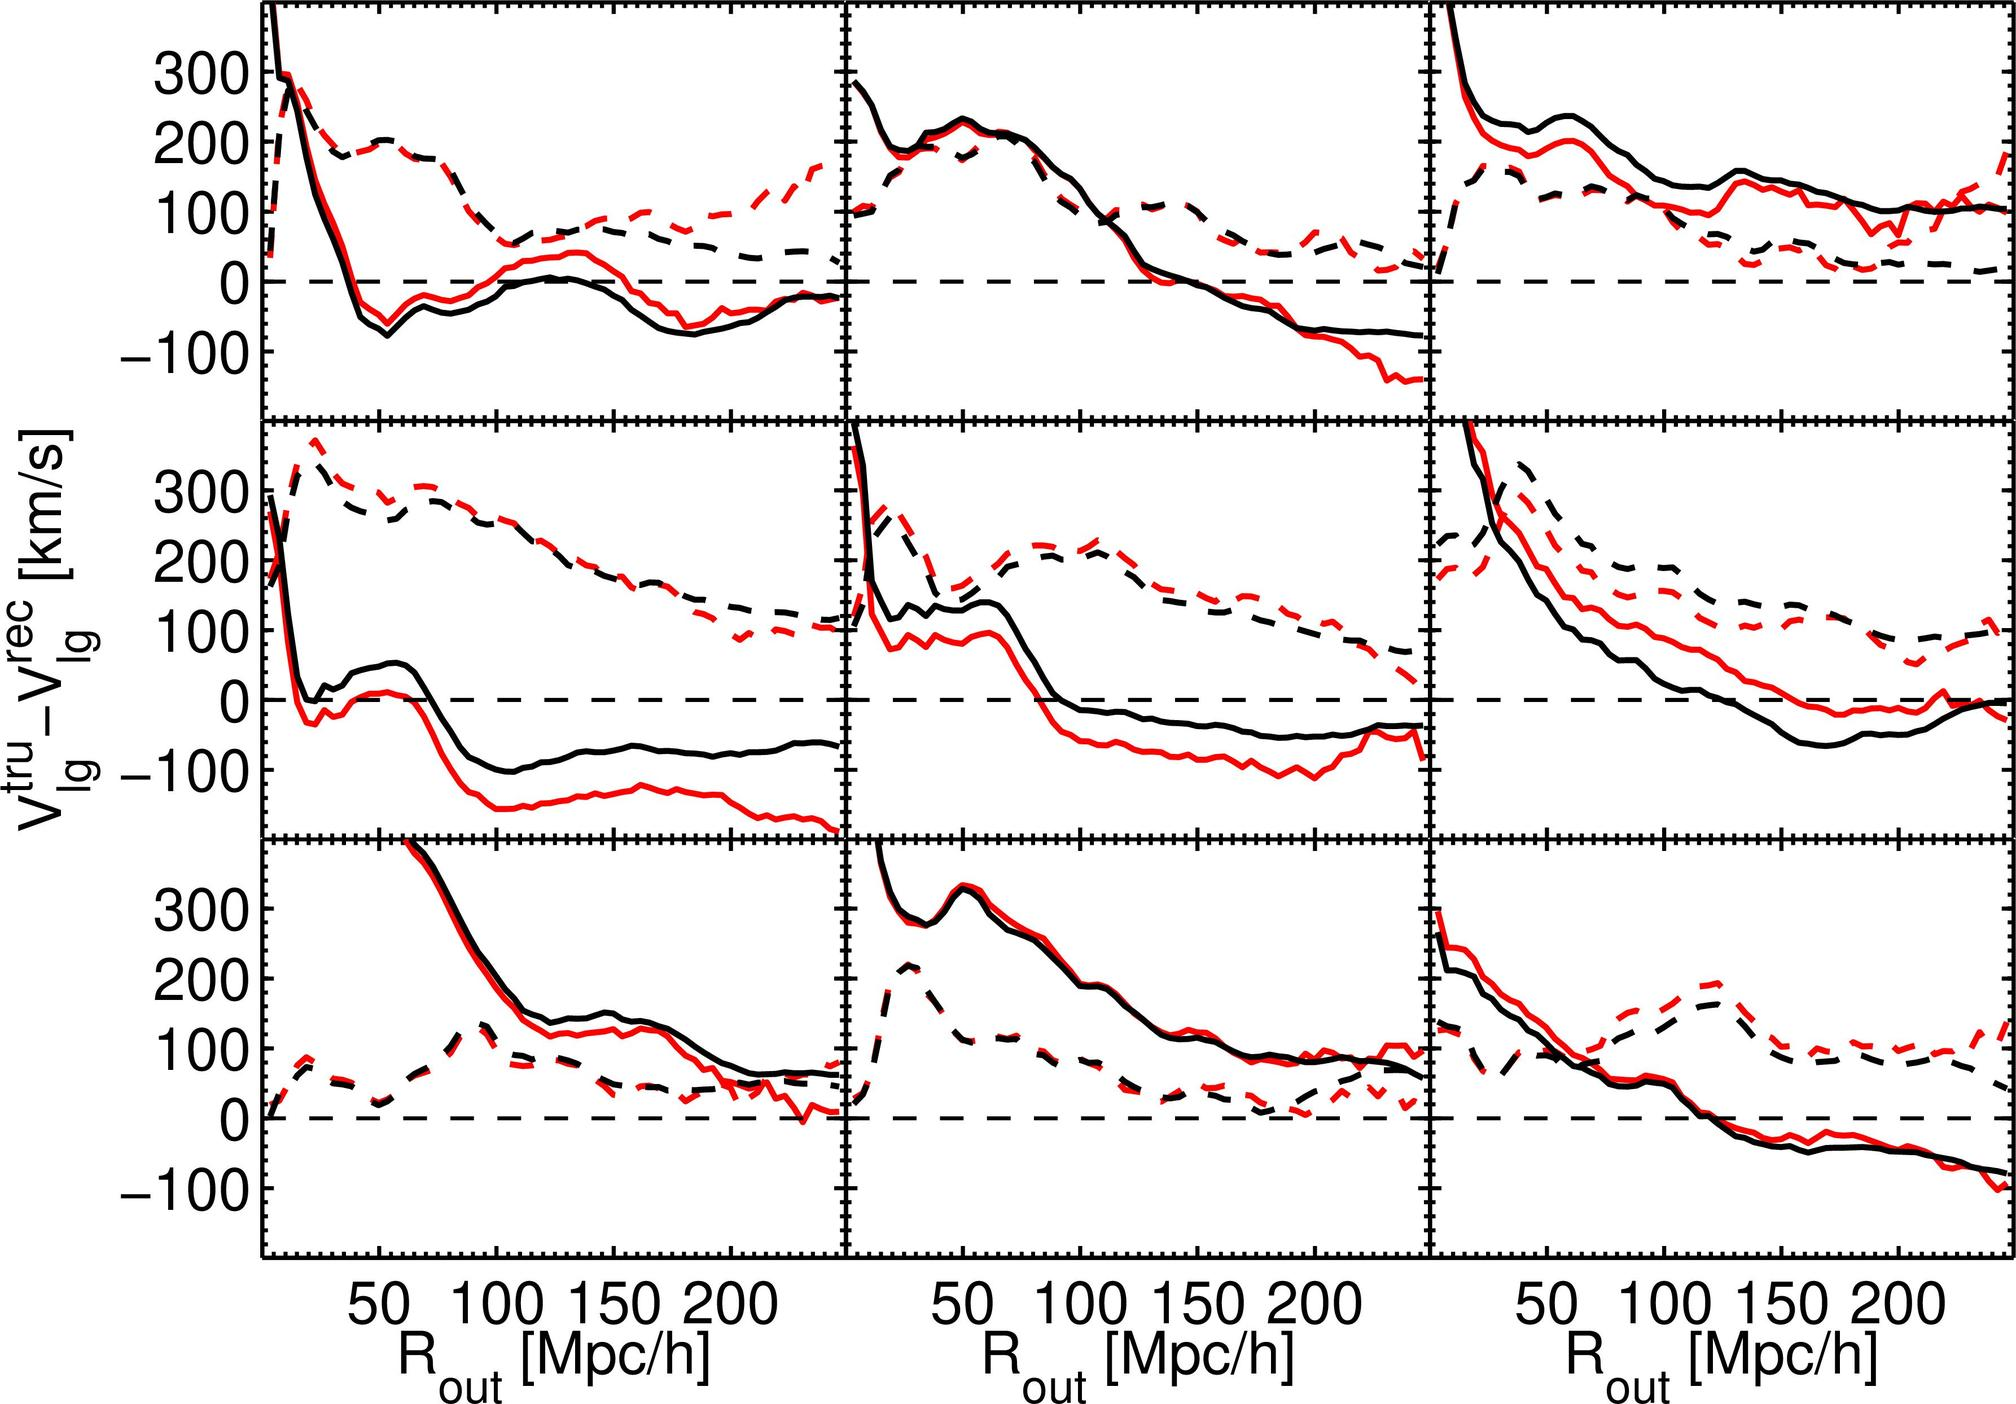How do these plots vary with changes in the R_out parameter? The plots show velocity differences for galaxies based on varying values of R_out, which represents a certain radial distance from a reference point, likely the observer or a central galaxy. As R_out changes, the behavior of the dashed and solid lines illustrate how galaxy velocities differ over distances, potentially shedding light on how galaxy properties and interactions change over space. 